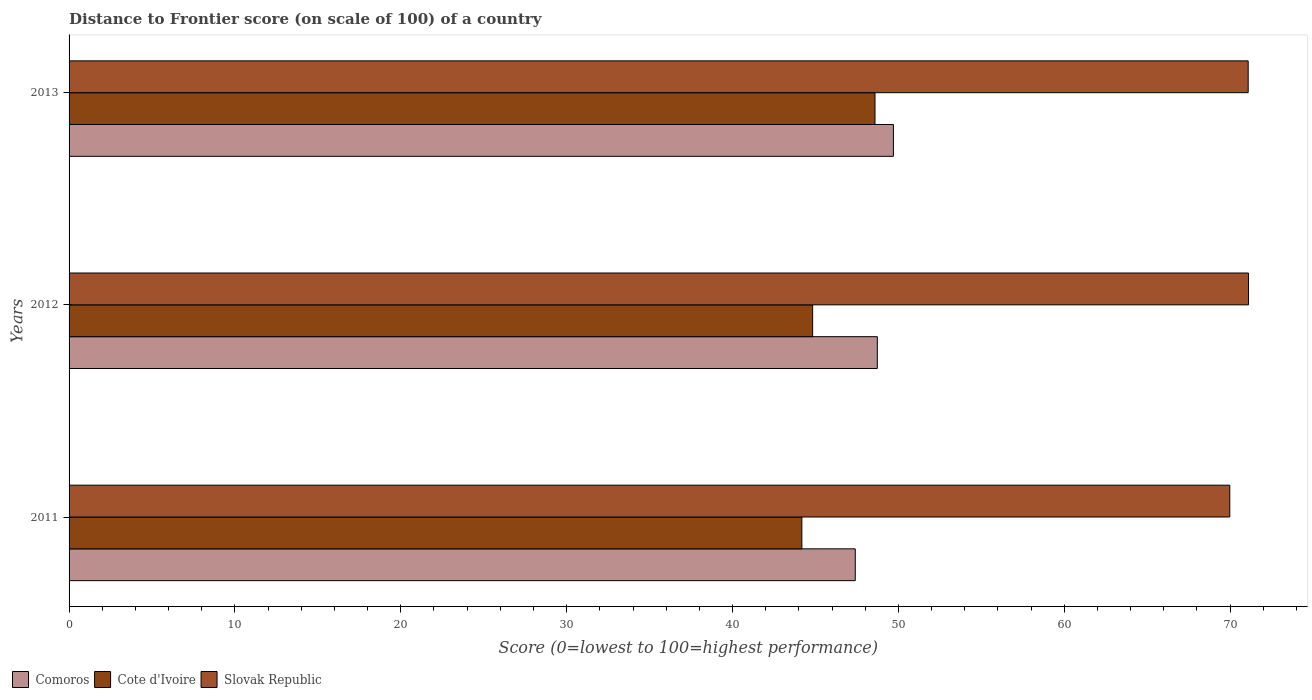How many groups of bars are there?
Make the answer very short. 3. How many bars are there on the 1st tick from the top?
Provide a short and direct response. 3. What is the label of the 3rd group of bars from the top?
Offer a very short reply. 2011. In how many cases, is the number of bars for a given year not equal to the number of legend labels?
Give a very brief answer. 0. What is the distance to frontier score of in Comoros in 2013?
Provide a succinct answer. 49.7. Across all years, what is the maximum distance to frontier score of in Cote d'Ivoire?
Keep it short and to the point. 48.59. Across all years, what is the minimum distance to frontier score of in Slovak Republic?
Provide a short and direct response. 69.98. In which year was the distance to frontier score of in Comoros minimum?
Your response must be concise. 2011. What is the total distance to frontier score of in Slovak Republic in the graph?
Offer a terse response. 212.18. What is the difference between the distance to frontier score of in Cote d'Ivoire in 2011 and that in 2013?
Make the answer very short. -4.41. What is the difference between the distance to frontier score of in Slovak Republic in 2011 and the distance to frontier score of in Cote d'Ivoire in 2013?
Offer a terse response. 21.39. What is the average distance to frontier score of in Cote d'Ivoire per year?
Offer a very short reply. 45.87. In the year 2011, what is the difference between the distance to frontier score of in Slovak Republic and distance to frontier score of in Comoros?
Offer a very short reply. 22.58. In how many years, is the distance to frontier score of in Comoros greater than 20 ?
Your answer should be very brief. 3. What is the ratio of the distance to frontier score of in Cote d'Ivoire in 2012 to that in 2013?
Provide a succinct answer. 0.92. Is the difference between the distance to frontier score of in Slovak Republic in 2012 and 2013 greater than the difference between the distance to frontier score of in Comoros in 2012 and 2013?
Offer a very short reply. Yes. What is the difference between the highest and the second highest distance to frontier score of in Comoros?
Provide a succinct answer. 0.97. What is the difference between the highest and the lowest distance to frontier score of in Cote d'Ivoire?
Offer a terse response. 4.41. In how many years, is the distance to frontier score of in Slovak Republic greater than the average distance to frontier score of in Slovak Republic taken over all years?
Offer a very short reply. 2. Is the sum of the distance to frontier score of in Cote d'Ivoire in 2011 and 2013 greater than the maximum distance to frontier score of in Slovak Republic across all years?
Your answer should be compact. Yes. What does the 3rd bar from the top in 2012 represents?
Ensure brevity in your answer.  Comoros. What does the 1st bar from the bottom in 2013 represents?
Give a very brief answer. Comoros. Is it the case that in every year, the sum of the distance to frontier score of in Slovak Republic and distance to frontier score of in Comoros is greater than the distance to frontier score of in Cote d'Ivoire?
Provide a short and direct response. Yes. How many bars are there?
Ensure brevity in your answer.  9. Are all the bars in the graph horizontal?
Keep it short and to the point. Yes. How many years are there in the graph?
Provide a succinct answer. 3. Where does the legend appear in the graph?
Make the answer very short. Bottom left. How are the legend labels stacked?
Ensure brevity in your answer.  Horizontal. What is the title of the graph?
Make the answer very short. Distance to Frontier score (on scale of 100) of a country. Does "Lebanon" appear as one of the legend labels in the graph?
Give a very brief answer. No. What is the label or title of the X-axis?
Provide a short and direct response. Score (0=lowest to 100=highest performance). What is the label or title of the Y-axis?
Your response must be concise. Years. What is the Score (0=lowest to 100=highest performance) of Comoros in 2011?
Offer a very short reply. 47.4. What is the Score (0=lowest to 100=highest performance) of Cote d'Ivoire in 2011?
Your answer should be very brief. 44.18. What is the Score (0=lowest to 100=highest performance) in Slovak Republic in 2011?
Offer a very short reply. 69.98. What is the Score (0=lowest to 100=highest performance) in Comoros in 2012?
Offer a terse response. 48.73. What is the Score (0=lowest to 100=highest performance) in Cote d'Ivoire in 2012?
Your answer should be very brief. 44.83. What is the Score (0=lowest to 100=highest performance) in Slovak Republic in 2012?
Offer a very short reply. 71.11. What is the Score (0=lowest to 100=highest performance) of Comoros in 2013?
Give a very brief answer. 49.7. What is the Score (0=lowest to 100=highest performance) in Cote d'Ivoire in 2013?
Ensure brevity in your answer.  48.59. What is the Score (0=lowest to 100=highest performance) of Slovak Republic in 2013?
Keep it short and to the point. 71.09. Across all years, what is the maximum Score (0=lowest to 100=highest performance) of Comoros?
Make the answer very short. 49.7. Across all years, what is the maximum Score (0=lowest to 100=highest performance) in Cote d'Ivoire?
Offer a terse response. 48.59. Across all years, what is the maximum Score (0=lowest to 100=highest performance) of Slovak Republic?
Offer a very short reply. 71.11. Across all years, what is the minimum Score (0=lowest to 100=highest performance) of Comoros?
Offer a very short reply. 47.4. Across all years, what is the minimum Score (0=lowest to 100=highest performance) in Cote d'Ivoire?
Ensure brevity in your answer.  44.18. Across all years, what is the minimum Score (0=lowest to 100=highest performance) of Slovak Republic?
Ensure brevity in your answer.  69.98. What is the total Score (0=lowest to 100=highest performance) of Comoros in the graph?
Your answer should be very brief. 145.83. What is the total Score (0=lowest to 100=highest performance) of Cote d'Ivoire in the graph?
Provide a short and direct response. 137.6. What is the total Score (0=lowest to 100=highest performance) in Slovak Republic in the graph?
Keep it short and to the point. 212.18. What is the difference between the Score (0=lowest to 100=highest performance) of Comoros in 2011 and that in 2012?
Your response must be concise. -1.33. What is the difference between the Score (0=lowest to 100=highest performance) in Cote d'Ivoire in 2011 and that in 2012?
Keep it short and to the point. -0.65. What is the difference between the Score (0=lowest to 100=highest performance) in Slovak Republic in 2011 and that in 2012?
Make the answer very short. -1.13. What is the difference between the Score (0=lowest to 100=highest performance) of Cote d'Ivoire in 2011 and that in 2013?
Give a very brief answer. -4.41. What is the difference between the Score (0=lowest to 100=highest performance) of Slovak Republic in 2011 and that in 2013?
Ensure brevity in your answer.  -1.11. What is the difference between the Score (0=lowest to 100=highest performance) in Comoros in 2012 and that in 2013?
Keep it short and to the point. -0.97. What is the difference between the Score (0=lowest to 100=highest performance) of Cote d'Ivoire in 2012 and that in 2013?
Offer a very short reply. -3.76. What is the difference between the Score (0=lowest to 100=highest performance) in Comoros in 2011 and the Score (0=lowest to 100=highest performance) in Cote d'Ivoire in 2012?
Offer a terse response. 2.57. What is the difference between the Score (0=lowest to 100=highest performance) of Comoros in 2011 and the Score (0=lowest to 100=highest performance) of Slovak Republic in 2012?
Offer a terse response. -23.71. What is the difference between the Score (0=lowest to 100=highest performance) in Cote d'Ivoire in 2011 and the Score (0=lowest to 100=highest performance) in Slovak Republic in 2012?
Provide a succinct answer. -26.93. What is the difference between the Score (0=lowest to 100=highest performance) in Comoros in 2011 and the Score (0=lowest to 100=highest performance) in Cote d'Ivoire in 2013?
Offer a terse response. -1.19. What is the difference between the Score (0=lowest to 100=highest performance) in Comoros in 2011 and the Score (0=lowest to 100=highest performance) in Slovak Republic in 2013?
Provide a short and direct response. -23.69. What is the difference between the Score (0=lowest to 100=highest performance) of Cote d'Ivoire in 2011 and the Score (0=lowest to 100=highest performance) of Slovak Republic in 2013?
Make the answer very short. -26.91. What is the difference between the Score (0=lowest to 100=highest performance) of Comoros in 2012 and the Score (0=lowest to 100=highest performance) of Cote d'Ivoire in 2013?
Keep it short and to the point. 0.14. What is the difference between the Score (0=lowest to 100=highest performance) of Comoros in 2012 and the Score (0=lowest to 100=highest performance) of Slovak Republic in 2013?
Make the answer very short. -22.36. What is the difference between the Score (0=lowest to 100=highest performance) of Cote d'Ivoire in 2012 and the Score (0=lowest to 100=highest performance) of Slovak Republic in 2013?
Provide a succinct answer. -26.26. What is the average Score (0=lowest to 100=highest performance) of Comoros per year?
Offer a very short reply. 48.61. What is the average Score (0=lowest to 100=highest performance) of Cote d'Ivoire per year?
Your answer should be very brief. 45.87. What is the average Score (0=lowest to 100=highest performance) of Slovak Republic per year?
Provide a short and direct response. 70.73. In the year 2011, what is the difference between the Score (0=lowest to 100=highest performance) in Comoros and Score (0=lowest to 100=highest performance) in Cote d'Ivoire?
Your answer should be very brief. 3.22. In the year 2011, what is the difference between the Score (0=lowest to 100=highest performance) of Comoros and Score (0=lowest to 100=highest performance) of Slovak Republic?
Your answer should be very brief. -22.58. In the year 2011, what is the difference between the Score (0=lowest to 100=highest performance) in Cote d'Ivoire and Score (0=lowest to 100=highest performance) in Slovak Republic?
Ensure brevity in your answer.  -25.8. In the year 2012, what is the difference between the Score (0=lowest to 100=highest performance) in Comoros and Score (0=lowest to 100=highest performance) in Slovak Republic?
Offer a very short reply. -22.38. In the year 2012, what is the difference between the Score (0=lowest to 100=highest performance) of Cote d'Ivoire and Score (0=lowest to 100=highest performance) of Slovak Republic?
Make the answer very short. -26.28. In the year 2013, what is the difference between the Score (0=lowest to 100=highest performance) in Comoros and Score (0=lowest to 100=highest performance) in Cote d'Ivoire?
Ensure brevity in your answer.  1.11. In the year 2013, what is the difference between the Score (0=lowest to 100=highest performance) in Comoros and Score (0=lowest to 100=highest performance) in Slovak Republic?
Make the answer very short. -21.39. In the year 2013, what is the difference between the Score (0=lowest to 100=highest performance) of Cote d'Ivoire and Score (0=lowest to 100=highest performance) of Slovak Republic?
Offer a very short reply. -22.5. What is the ratio of the Score (0=lowest to 100=highest performance) of Comoros in 2011 to that in 2012?
Give a very brief answer. 0.97. What is the ratio of the Score (0=lowest to 100=highest performance) of Cote d'Ivoire in 2011 to that in 2012?
Keep it short and to the point. 0.99. What is the ratio of the Score (0=lowest to 100=highest performance) in Slovak Republic in 2011 to that in 2012?
Ensure brevity in your answer.  0.98. What is the ratio of the Score (0=lowest to 100=highest performance) in Comoros in 2011 to that in 2013?
Ensure brevity in your answer.  0.95. What is the ratio of the Score (0=lowest to 100=highest performance) in Cote d'Ivoire in 2011 to that in 2013?
Give a very brief answer. 0.91. What is the ratio of the Score (0=lowest to 100=highest performance) in Slovak Republic in 2011 to that in 2013?
Provide a short and direct response. 0.98. What is the ratio of the Score (0=lowest to 100=highest performance) of Comoros in 2012 to that in 2013?
Make the answer very short. 0.98. What is the ratio of the Score (0=lowest to 100=highest performance) in Cote d'Ivoire in 2012 to that in 2013?
Offer a terse response. 0.92. What is the ratio of the Score (0=lowest to 100=highest performance) in Slovak Republic in 2012 to that in 2013?
Your answer should be very brief. 1. What is the difference between the highest and the second highest Score (0=lowest to 100=highest performance) of Cote d'Ivoire?
Provide a short and direct response. 3.76. What is the difference between the highest and the lowest Score (0=lowest to 100=highest performance) in Comoros?
Provide a succinct answer. 2.3. What is the difference between the highest and the lowest Score (0=lowest to 100=highest performance) in Cote d'Ivoire?
Provide a succinct answer. 4.41. What is the difference between the highest and the lowest Score (0=lowest to 100=highest performance) of Slovak Republic?
Offer a terse response. 1.13. 